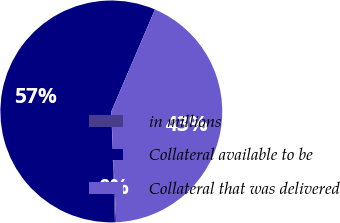<chart> <loc_0><loc_0><loc_500><loc_500><pie_chart><fcel>in millions<fcel>Collateral available to be<fcel>Collateral that was delivered<nl><fcel>0.18%<fcel>56.96%<fcel>42.86%<nl></chart> 